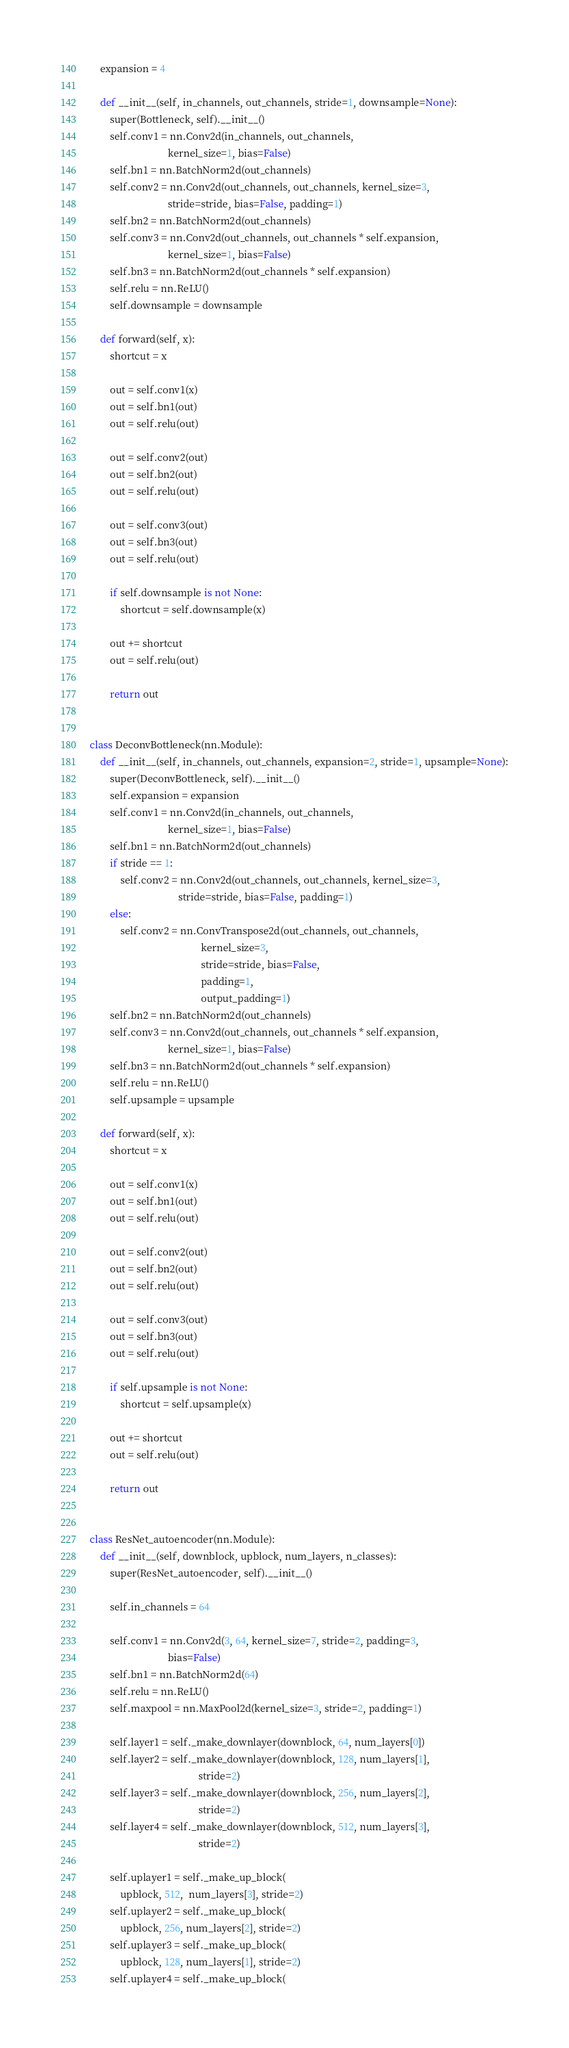<code> <loc_0><loc_0><loc_500><loc_500><_Python_>    expansion = 4

    def __init__(self, in_channels, out_channels, stride=1, downsample=None):
        super(Bottleneck, self).__init__()
        self.conv1 = nn.Conv2d(in_channels, out_channels,
                               kernel_size=1, bias=False)
        self.bn1 = nn.BatchNorm2d(out_channels)
        self.conv2 = nn.Conv2d(out_channels, out_channels, kernel_size=3,
                               stride=stride, bias=False, padding=1)
        self.bn2 = nn.BatchNorm2d(out_channels)
        self.conv3 = nn.Conv2d(out_channels, out_channels * self.expansion,
                               kernel_size=1, bias=False)
        self.bn3 = nn.BatchNorm2d(out_channels * self.expansion)
        self.relu = nn.ReLU()
        self.downsample = downsample

    def forward(self, x):
        shortcut = x

        out = self.conv1(x)
        out = self.bn1(out)
        out = self.relu(out)

        out = self.conv2(out)
        out = self.bn2(out)
        out = self.relu(out)

        out = self.conv3(out)
        out = self.bn3(out)
        out = self.relu(out)

        if self.downsample is not None:
            shortcut = self.downsample(x)

        out += shortcut
        out = self.relu(out)

        return out


class DeconvBottleneck(nn.Module):
    def __init__(self, in_channels, out_channels, expansion=2, stride=1, upsample=None):
        super(DeconvBottleneck, self).__init__()
        self.expansion = expansion
        self.conv1 = nn.Conv2d(in_channels, out_channels,
                               kernel_size=1, bias=False)
        self.bn1 = nn.BatchNorm2d(out_channels)
        if stride == 1:
            self.conv2 = nn.Conv2d(out_channels, out_channels, kernel_size=3,
                                   stride=stride, bias=False, padding=1)
        else:
            self.conv2 = nn.ConvTranspose2d(out_channels, out_channels,
                                            kernel_size=3,
                                            stride=stride, bias=False,
                                            padding=1,
                                            output_padding=1)
        self.bn2 = nn.BatchNorm2d(out_channels)
        self.conv3 = nn.Conv2d(out_channels, out_channels * self.expansion,
                               kernel_size=1, bias=False)
        self.bn3 = nn.BatchNorm2d(out_channels * self.expansion)
        self.relu = nn.ReLU()
        self.upsample = upsample

    def forward(self, x):
        shortcut = x

        out = self.conv1(x)
        out = self.bn1(out)
        out = self.relu(out)

        out = self.conv2(out)
        out = self.bn2(out)
        out = self.relu(out)

        out = self.conv3(out)
        out = self.bn3(out)
        out = self.relu(out)

        if self.upsample is not None:
            shortcut = self.upsample(x)

        out += shortcut
        out = self.relu(out)

        return out


class ResNet_autoencoder(nn.Module):
    def __init__(self, downblock, upblock, num_layers, n_classes):
        super(ResNet_autoencoder, self).__init__()

        self.in_channels = 64

        self.conv1 = nn.Conv2d(3, 64, kernel_size=7, stride=2, padding=3,
                               bias=False)
        self.bn1 = nn.BatchNorm2d(64)
        self.relu = nn.ReLU()
        self.maxpool = nn.MaxPool2d(kernel_size=3, stride=2, padding=1)

        self.layer1 = self._make_downlayer(downblock, 64, num_layers[0])
        self.layer2 = self._make_downlayer(downblock, 128, num_layers[1],
                                           stride=2)
        self.layer3 = self._make_downlayer(downblock, 256, num_layers[2],
                                           stride=2)
        self.layer4 = self._make_downlayer(downblock, 512, num_layers[3],
                                           stride=2)

        self.uplayer1 = self._make_up_block(
            upblock, 512,  num_layers[3], stride=2)
        self.uplayer2 = self._make_up_block(
            upblock, 256, num_layers[2], stride=2)
        self.uplayer3 = self._make_up_block(
            upblock, 128, num_layers[1], stride=2)
        self.uplayer4 = self._make_up_block(</code> 